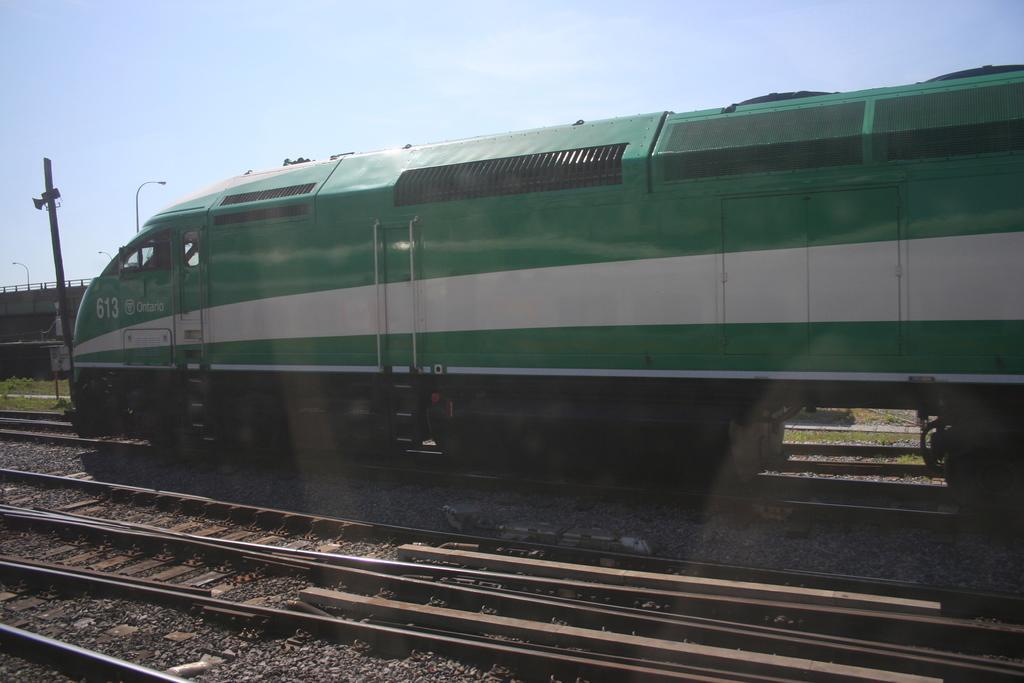How would you summarize this image in a sentence or two? In this image, we can see a train on the track. At the bottom, we can see few tracks. On the left side of the image, we can see few poles, grass, board, railing. Background there is a sky. 